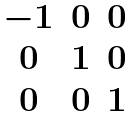Convert formula to latex. <formula><loc_0><loc_0><loc_500><loc_500>\begin{matrix} - 1 & 0 & 0 \\ 0 & 1 & 0 \\ 0 & 0 & 1 \end{matrix}</formula> 